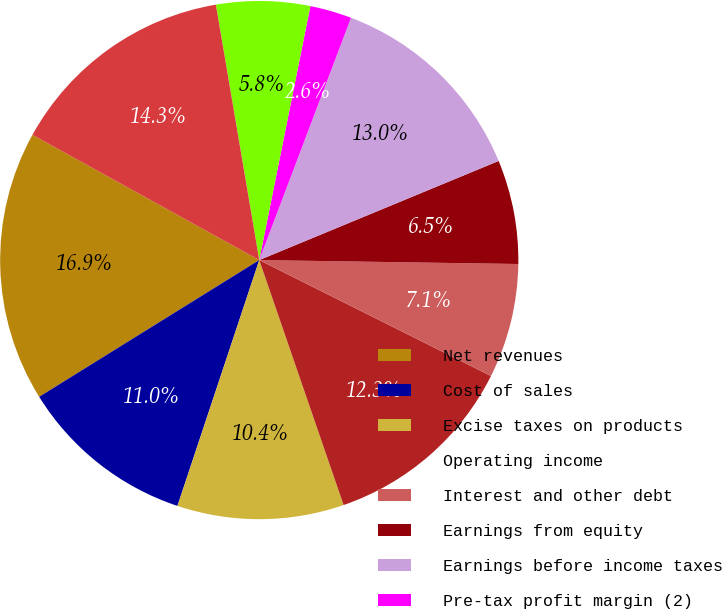Convert chart. <chart><loc_0><loc_0><loc_500><loc_500><pie_chart><fcel>Net revenues<fcel>Cost of sales<fcel>Excise taxes on products<fcel>Operating income<fcel>Interest and other debt<fcel>Earnings from equity<fcel>Earnings before income taxes<fcel>Pre-tax profit margin (2)<fcel>(Benefit) provision for income<fcel>Net earnings (1)(2)<nl><fcel>16.88%<fcel>11.04%<fcel>10.39%<fcel>12.34%<fcel>7.14%<fcel>6.49%<fcel>12.99%<fcel>2.6%<fcel>5.84%<fcel>14.29%<nl></chart> 